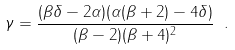<formula> <loc_0><loc_0><loc_500><loc_500>\gamma = \frac { ( \beta \delta - 2 \alpha ) ( \alpha ( \beta + 2 ) - 4 \delta ) } { ( \beta - 2 ) ( \beta + 4 ) ^ { 2 } } \ .</formula> 